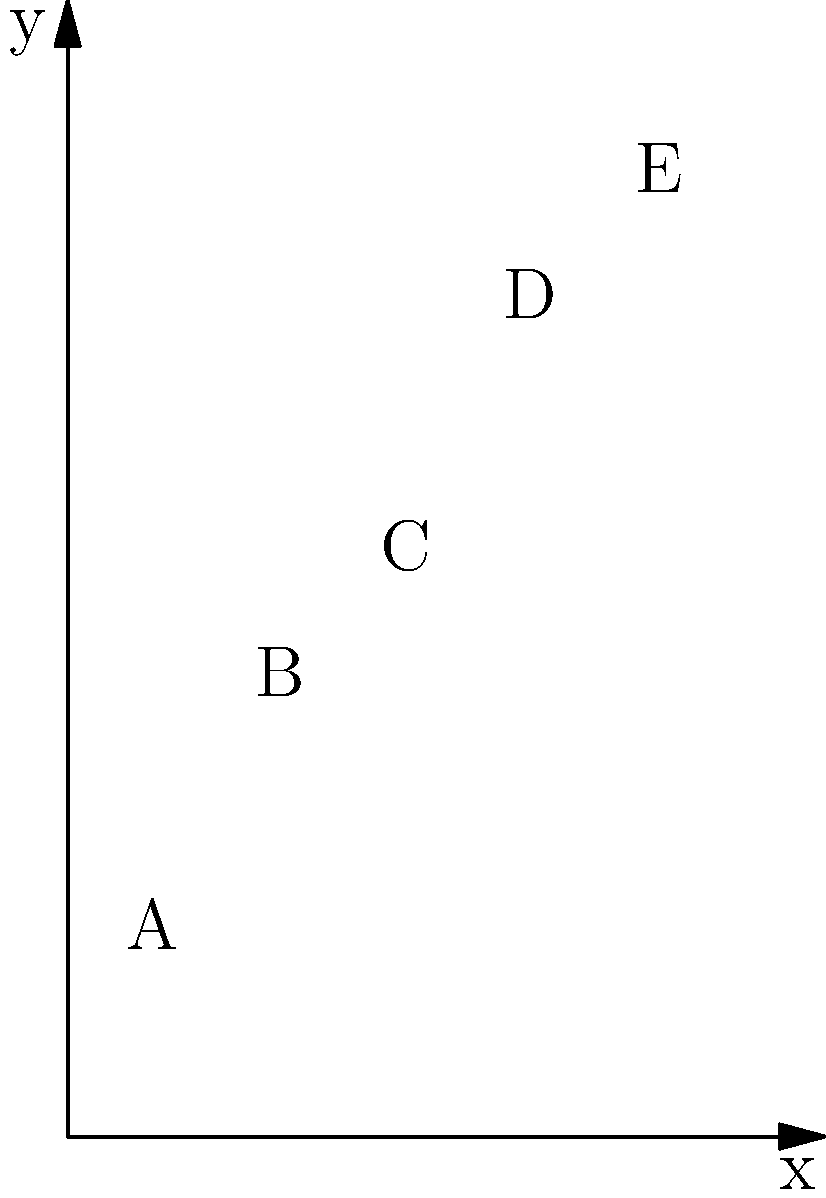As a recycled material artist, you're planning to ship your artwork in custom-made boxes. The graph shows the relationship between the box dimensions (x-axis) and the shipping cost (y-axis) for five different box sizes (A, B, C, D, E). Which box size offers the most cost-effective solution for shipping your artwork, considering both the box size and shipping cost? Use the concept of slope to determine the best option. To find the most cost-effective box size, we need to calculate the slope between consecutive points. The slope represents the rate of change in shipping cost relative to the change in box size.

1. Calculate slopes between consecutive points:
   
   Slope(A to B) = $\frac{4-2}{2-1} = 2$
   Slope(B to C) = $\frac{5-4}{3-2} = 1$
   Slope(C to D) = $\frac{7-5}{4-3} = 2$
   Slope(D to E) = $\frac{8-7}{5-4} = 1$

2. Analyze the slopes:
   - A lower slope indicates a smaller increase in shipping cost relative to the increase in box size.
   - The slopes between B and C, and between D and E, are both 1, which is the lowest.

3. Compare the two options with the lowest slope:
   - B to C: Box size increases from 2 to 3, shipping cost from 4 to 5
   - D to E: Box size increases from 4 to 5, shipping cost from 7 to 8

4. Choose the best option:
   - B to C offers a larger box size increase (50% larger) for a smaller absolute cost increase ($1).
   - D to E offers a smaller box size increase (25% larger) for the same absolute cost increase ($1).

Therefore, the most cost-effective solution is to choose box size C (3, 5), as it provides the best balance between box size and shipping cost.
Answer: Box size C (3, 5) 